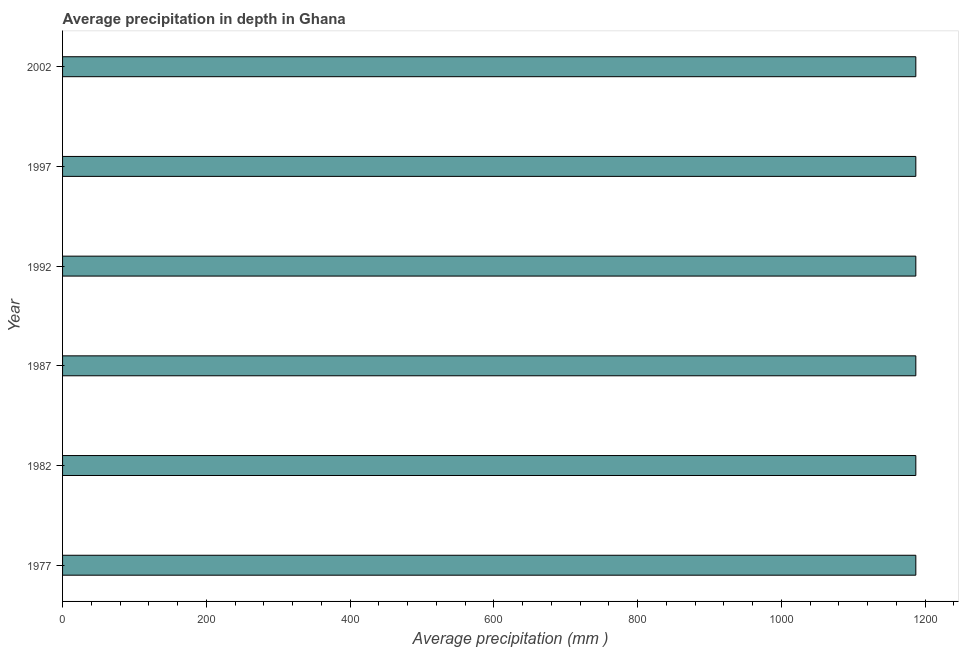Does the graph contain grids?
Keep it short and to the point. No. What is the title of the graph?
Provide a short and direct response. Average precipitation in depth in Ghana. What is the label or title of the X-axis?
Your response must be concise. Average precipitation (mm ). What is the label or title of the Y-axis?
Ensure brevity in your answer.  Year. What is the average precipitation in depth in 1977?
Keep it short and to the point. 1187. Across all years, what is the maximum average precipitation in depth?
Your response must be concise. 1187. Across all years, what is the minimum average precipitation in depth?
Offer a terse response. 1187. In which year was the average precipitation in depth minimum?
Provide a short and direct response. 1977. What is the sum of the average precipitation in depth?
Make the answer very short. 7122. What is the average average precipitation in depth per year?
Provide a succinct answer. 1187. What is the median average precipitation in depth?
Offer a terse response. 1187. What is the ratio of the average precipitation in depth in 1987 to that in 2002?
Offer a very short reply. 1. Is the difference between the average precipitation in depth in 1977 and 1987 greater than the difference between any two years?
Your answer should be compact. Yes. What is the difference between the highest and the second highest average precipitation in depth?
Provide a short and direct response. 0. Is the sum of the average precipitation in depth in 1982 and 2002 greater than the maximum average precipitation in depth across all years?
Provide a succinct answer. Yes. Are all the bars in the graph horizontal?
Provide a short and direct response. Yes. How many years are there in the graph?
Your answer should be very brief. 6. What is the Average precipitation (mm ) in 1977?
Provide a succinct answer. 1187. What is the Average precipitation (mm ) of 1982?
Keep it short and to the point. 1187. What is the Average precipitation (mm ) in 1987?
Provide a succinct answer. 1187. What is the Average precipitation (mm ) in 1992?
Give a very brief answer. 1187. What is the Average precipitation (mm ) of 1997?
Ensure brevity in your answer.  1187. What is the Average precipitation (mm ) of 2002?
Make the answer very short. 1187. What is the difference between the Average precipitation (mm ) in 1977 and 1982?
Your answer should be compact. 0. What is the difference between the Average precipitation (mm ) in 1977 and 1997?
Offer a very short reply. 0. What is the difference between the Average precipitation (mm ) in 1982 and 1987?
Your answer should be compact. 0. What is the difference between the Average precipitation (mm ) in 1982 and 1992?
Give a very brief answer. 0. What is the difference between the Average precipitation (mm ) in 1992 and 1997?
Keep it short and to the point. 0. What is the difference between the Average precipitation (mm ) in 1992 and 2002?
Offer a terse response. 0. What is the ratio of the Average precipitation (mm ) in 1977 to that in 1982?
Your answer should be compact. 1. What is the ratio of the Average precipitation (mm ) in 1977 to that in 1987?
Ensure brevity in your answer.  1. What is the ratio of the Average precipitation (mm ) in 1977 to that in 1992?
Provide a short and direct response. 1. What is the ratio of the Average precipitation (mm ) in 1977 to that in 2002?
Provide a short and direct response. 1. What is the ratio of the Average precipitation (mm ) in 1982 to that in 2002?
Your response must be concise. 1. What is the ratio of the Average precipitation (mm ) in 1987 to that in 1992?
Provide a succinct answer. 1. What is the ratio of the Average precipitation (mm ) in 1992 to that in 2002?
Offer a terse response. 1. What is the ratio of the Average precipitation (mm ) in 1997 to that in 2002?
Provide a succinct answer. 1. 